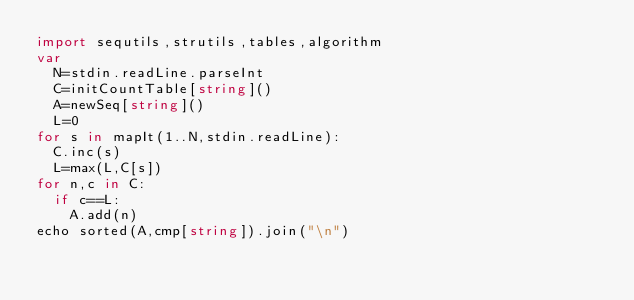<code> <loc_0><loc_0><loc_500><loc_500><_Nim_>import sequtils,strutils,tables,algorithm
var
  N=stdin.readLine.parseInt
  C=initCountTable[string]()
  A=newSeq[string]()
  L=0
for s in mapIt(1..N,stdin.readLine):
  C.inc(s)
  L=max(L,C[s])
for n,c in C:
  if c==L:
    A.add(n)
echo sorted(A,cmp[string]).join("\n")</code> 